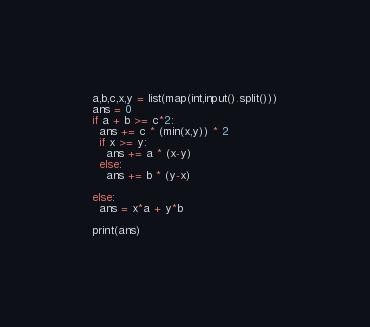Convert code to text. <code><loc_0><loc_0><loc_500><loc_500><_Python_>a,b,c,x,y = list(map(int,input().split()))
ans = 0
if a + b >= c*2:
  ans += c * (min(x,y)) * 2
  if x >= y:
    ans += a * (x-y)
  else:
    ans += b * (y-x)
    
else:
  ans = x*a + y*b
  
print(ans)</code> 